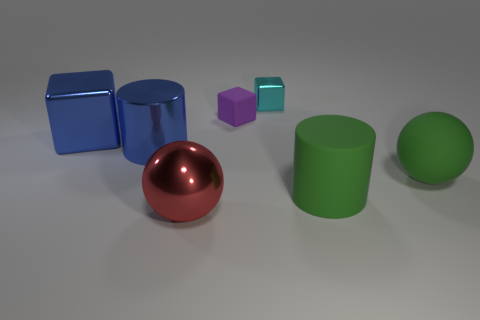Add 1 large red things. How many objects exist? 8 Subtract all cylinders. How many objects are left? 5 Add 5 matte objects. How many matte objects are left? 8 Add 2 tiny cyan metallic things. How many tiny cyan metallic things exist? 3 Subtract 1 red balls. How many objects are left? 6 Subtract all tiny metallic objects. Subtract all metal blocks. How many objects are left? 4 